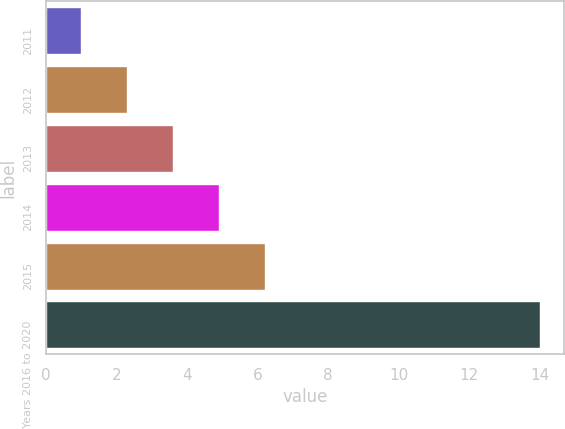Convert chart. <chart><loc_0><loc_0><loc_500><loc_500><bar_chart><fcel>2011<fcel>2012<fcel>2013<fcel>2014<fcel>2015<fcel>Years 2016 to 2020<nl><fcel>1<fcel>2.3<fcel>3.6<fcel>4.9<fcel>6.2<fcel>14<nl></chart> 